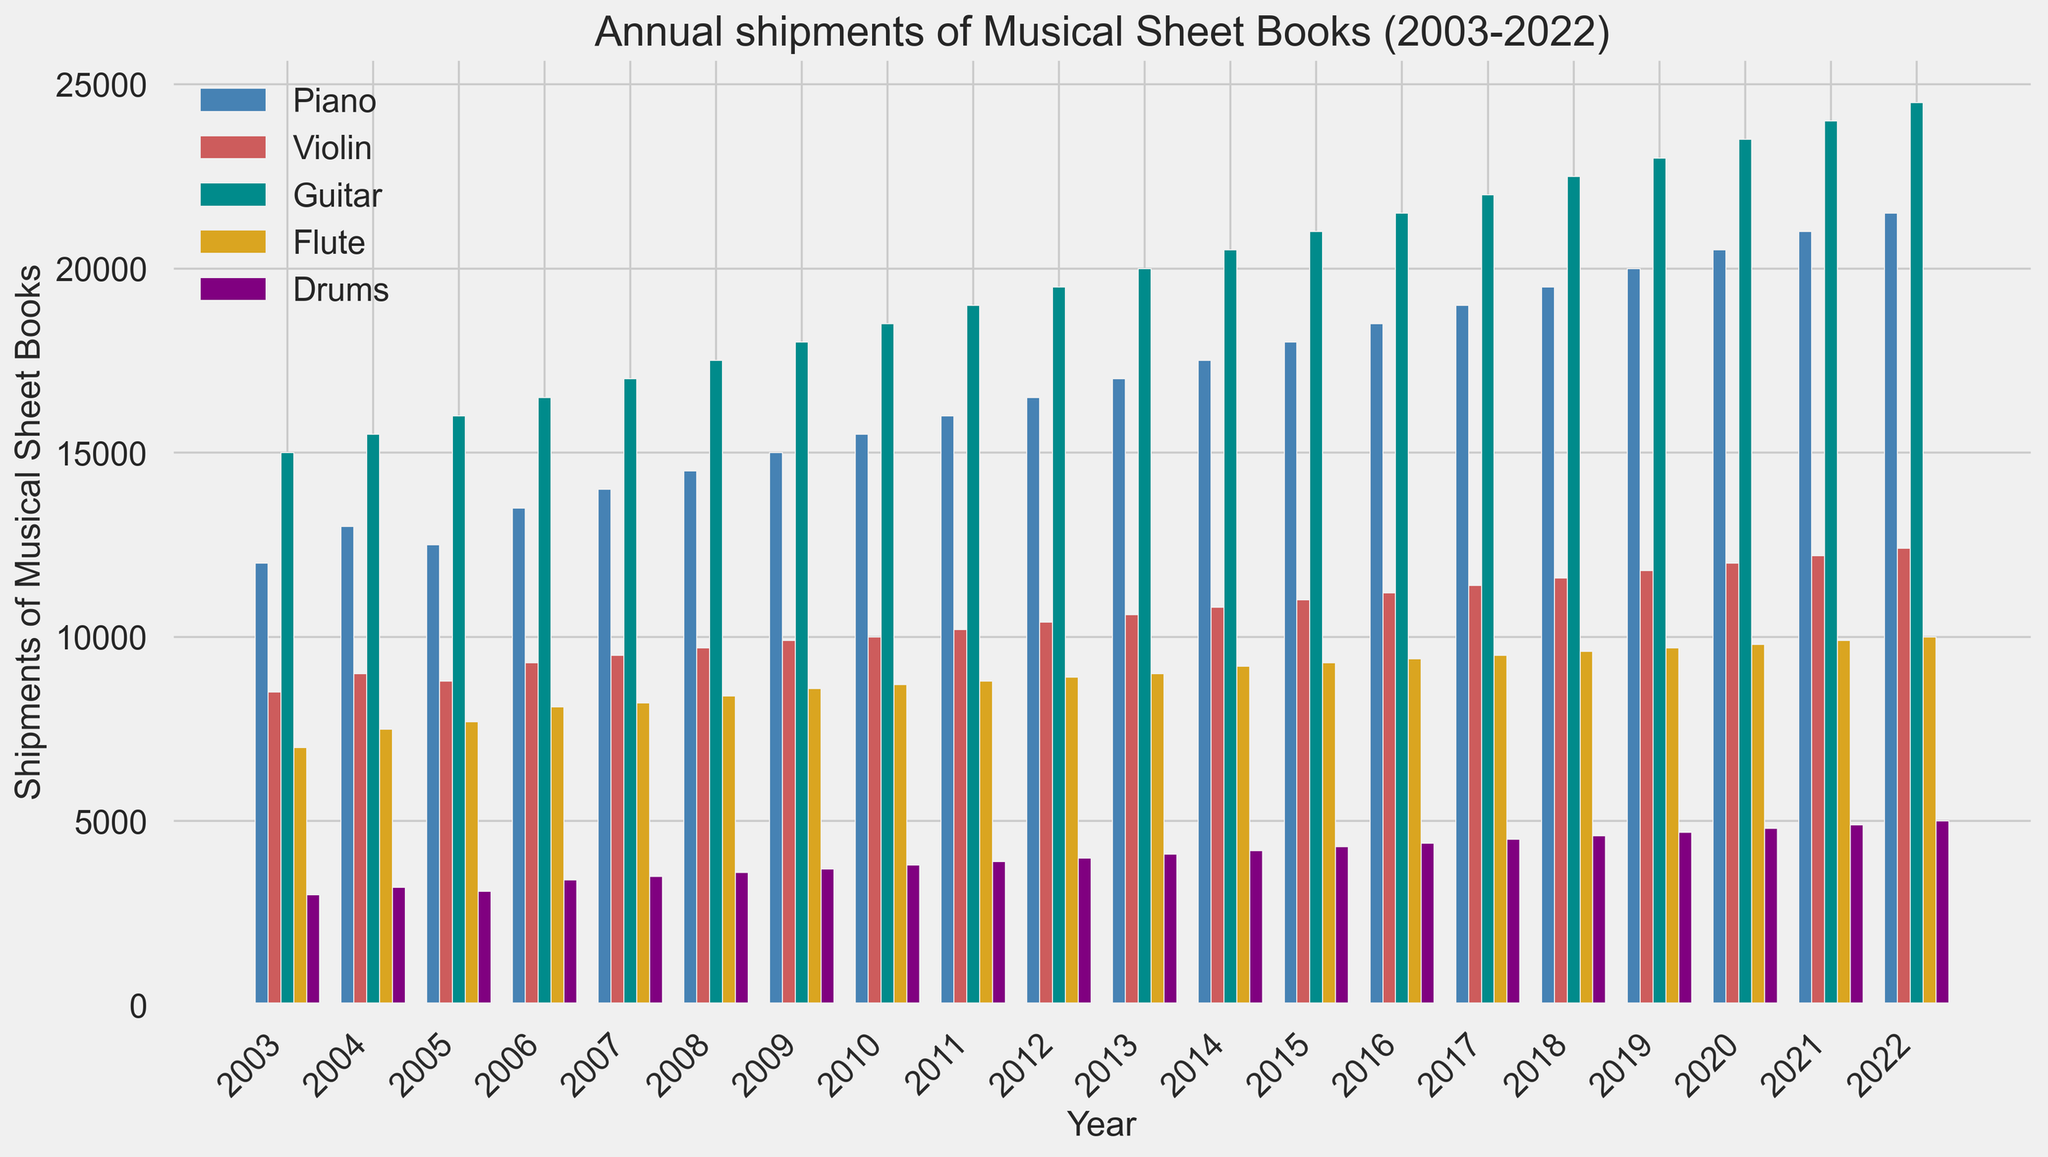What's the general trend of shipments for Guitar books from 2003 to 2022? To determine the trend, look at the heights of the bars for Guitar shipments for each year from 2003 to 2022. Notice that the Guitar shipment bars consistently rise each year, indicating a steady increase in Guitar book shipments.
Answer: Steady increase Which instrument had the lowest shipment in 2003? To find the lowest shipment in 2003, compare the heights of the bars for each instrument in the year 2003. The Drums bar is the shortest, indicating it had the lowest shipments.
Answer: Drums Between 2015 and 2020, which instrument saw the highest increase in shipments? To identify the highest increase, look at the bar heights for each instrument in 2015 and 2020. Calculate the difference for each instrument: Piano (20500-18000=2500), Violin (12000-11000=1000), Guitar (23500-21000=2500), Flute (9800-9300=500), Drums (4800-4300=500). Piano and Guitar both have an increase of 2500, the highest.
Answer: Piano and Guitar By how much did shipments of Piano books increase from 2003 to 2013? First, note the heights of the Piano bars in 2003 and 2013. Shipments in 2003 were 12000, and in 2013 were 17000. The increase is calculated as 17000 - 12000 = 5000.
Answer: 5000 Which year did Flute shipments first surpass 9000? Find the year when the Flute bar height first exceeds 9000. This happens in 2014 (or earlier, 2013).
Answer: 2014 In 2022, which instrument had nearly double the shipments compared to Drums? Compare the bar heights for each instrument in 2022 with that of Drums (5000). The Guitar bar is significantly higher, with shipments of 24500, which is nearly five times higher than Drums. To find nearly double, compare with other heights: Flute (10000, exactly double), so nearly double the shipments would still be Flute.
Answer: Flute What is the cumulative shipment of Violin books from 2010 to 2015? Add the shipments of Violin books from 2010 to 2015: 10000 (2010) + 10200 (2011) + 10400 (2012) + 10600 (2013) + 10800 (2014) + 11000 (2015) = 63000.
Answer: 63000 Compare the shipment trends of Piano and Drums over the 20-year span. Which had a more significant increase? Analyze the heights of the bars for Piano and Drums across all years. Piano shipments increased from 12000 in 2003 to 21500 in 2022 (9500 increase), whereas Drums increased from 3000 to 5000 (2000 increase).
Answer: Piano From 2008 to 2013, which instrument experienced a consistent year-on-year increase? Observe the bar heights for each instrument from 2008 to 2013:
- Piano (14500 to 17000, increase each year)
- Violin (9700 to 10800, increase each year)
- Guitar (17500 to 20000, increase each year)
- Flute (8400 to 9000, increase each year)
- Drums (3600 to 4100, increase each year)
All instruments experienced consistent year-on-year increases, but Guitar marked the highest consistency.
Answer: Guitar What's the difference between the highest and lowest shipments of Guitar books across all years? Identify the highest shipment year for Guitar (24500 in 2022) and the lowest shipment year (15000 in 2003). Calculate the difference: 24500 - 15000 = 9500.
Answer: 9500 